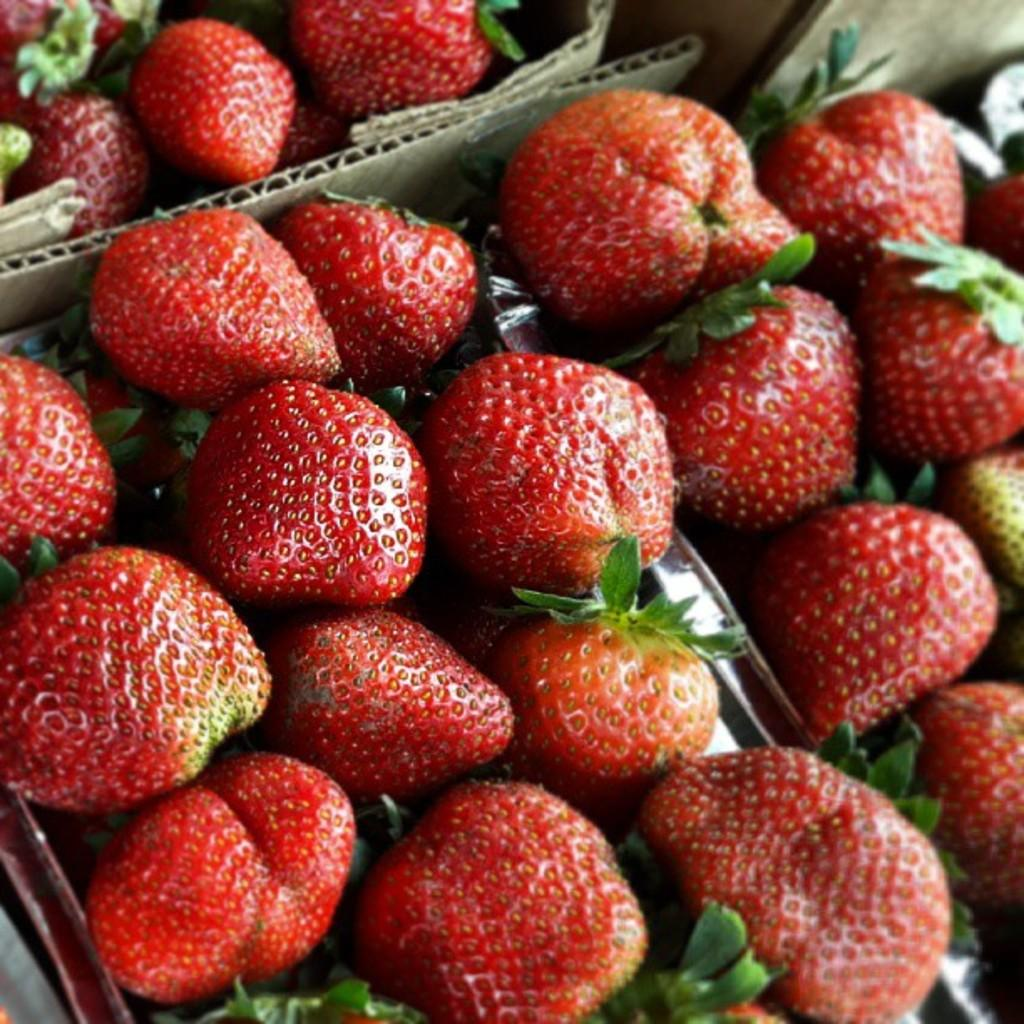What types of items can be seen in the image? There are food items in the image. How are the food items arranged or contained? The food items are in an object. What type of goose is sitting on the sun in the image? There is no goose or sun present in the image; it only features food items in an object. 